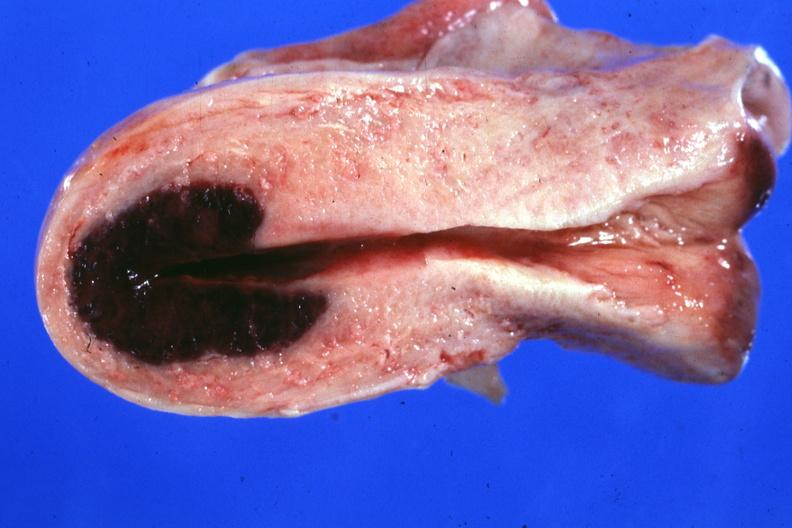why does this image show localized lesion in dome of uterus said to have adenosis adenomyosis hemorrhage probably?
Answer the question using a single word or phrase. Due shock 